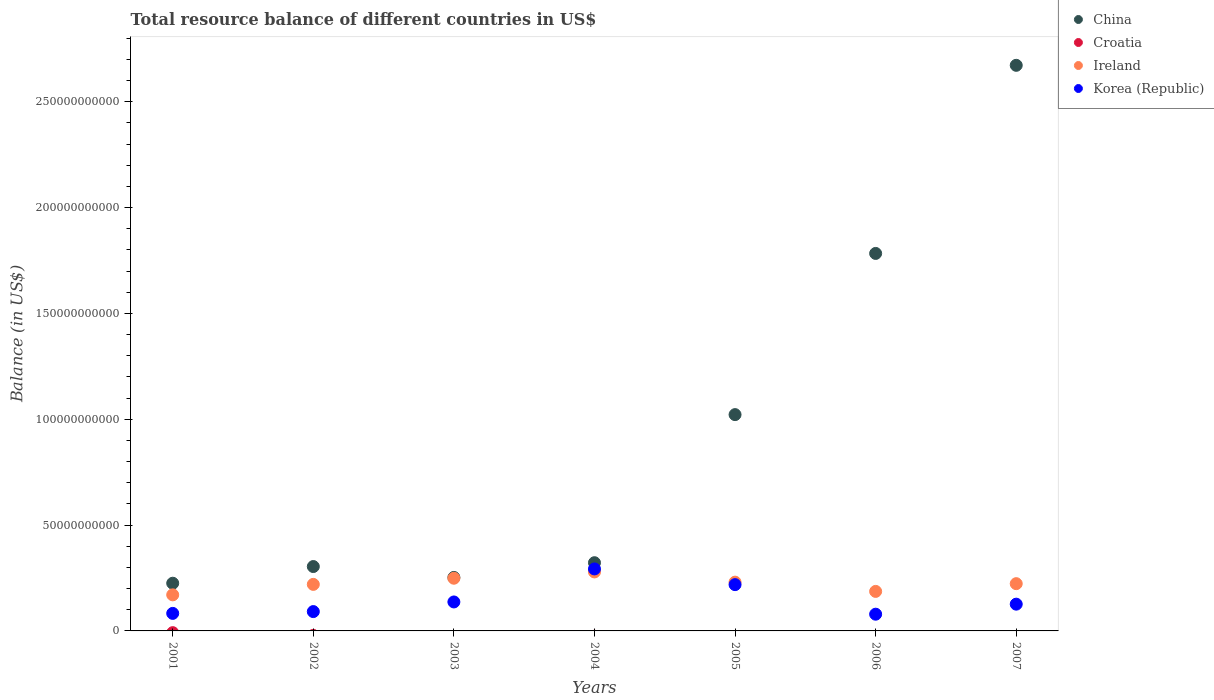Is the number of dotlines equal to the number of legend labels?
Offer a very short reply. No. What is the total resource balance in Korea (Republic) in 2006?
Offer a very short reply. 7.90e+09. Across all years, what is the maximum total resource balance in Korea (Republic)?
Offer a terse response. 2.93e+1. Across all years, what is the minimum total resource balance in Ireland?
Give a very brief answer. 1.70e+1. In which year was the total resource balance in Korea (Republic) maximum?
Provide a succinct answer. 2004. What is the total total resource balance in China in the graph?
Offer a very short reply. 6.58e+11. What is the difference between the total resource balance in Korea (Republic) in 2004 and that in 2005?
Provide a short and direct response. 7.42e+09. What is the difference between the total resource balance in Croatia in 2006 and the total resource balance in China in 2001?
Offer a very short reply. -2.25e+1. What is the average total resource balance in China per year?
Make the answer very short. 9.40e+1. In the year 2006, what is the difference between the total resource balance in China and total resource balance in Korea (Republic)?
Provide a short and direct response. 1.70e+11. What is the ratio of the total resource balance in Korea (Republic) in 2002 to that in 2003?
Make the answer very short. 0.67. Is the difference between the total resource balance in China in 2001 and 2003 greater than the difference between the total resource balance in Korea (Republic) in 2001 and 2003?
Provide a succinct answer. Yes. What is the difference between the highest and the second highest total resource balance in China?
Provide a short and direct response. 8.89e+1. What is the difference between the highest and the lowest total resource balance in China?
Give a very brief answer. 2.45e+11. Is the sum of the total resource balance in China in 2002 and 2007 greater than the maximum total resource balance in Ireland across all years?
Keep it short and to the point. Yes. Is it the case that in every year, the sum of the total resource balance in Korea (Republic) and total resource balance in Croatia  is greater than the total resource balance in Ireland?
Your answer should be very brief. No. Does the total resource balance in Croatia monotonically increase over the years?
Provide a short and direct response. No. Is the total resource balance in Korea (Republic) strictly less than the total resource balance in China over the years?
Provide a succinct answer. Yes. Does the graph contain any zero values?
Your answer should be very brief. Yes. How are the legend labels stacked?
Ensure brevity in your answer.  Vertical. What is the title of the graph?
Keep it short and to the point. Total resource balance of different countries in US$. What is the label or title of the Y-axis?
Make the answer very short. Balance (in US$). What is the Balance (in US$) of China in 2001?
Ensure brevity in your answer.  2.25e+1. What is the Balance (in US$) in Croatia in 2001?
Your answer should be very brief. 0. What is the Balance (in US$) of Ireland in 2001?
Provide a short and direct response. 1.70e+1. What is the Balance (in US$) of Korea (Republic) in 2001?
Offer a terse response. 8.28e+09. What is the Balance (in US$) in China in 2002?
Provide a succinct answer. 3.04e+1. What is the Balance (in US$) of Croatia in 2002?
Give a very brief answer. 0. What is the Balance (in US$) of Ireland in 2002?
Ensure brevity in your answer.  2.20e+1. What is the Balance (in US$) of Korea (Republic) in 2002?
Provide a short and direct response. 9.14e+09. What is the Balance (in US$) in China in 2003?
Make the answer very short. 2.53e+1. What is the Balance (in US$) in Croatia in 2003?
Keep it short and to the point. 0. What is the Balance (in US$) of Ireland in 2003?
Your answer should be very brief. 2.49e+1. What is the Balance (in US$) of Korea (Republic) in 2003?
Make the answer very short. 1.37e+1. What is the Balance (in US$) in China in 2004?
Your answer should be compact. 3.22e+1. What is the Balance (in US$) in Ireland in 2004?
Offer a terse response. 2.79e+1. What is the Balance (in US$) in Korea (Republic) in 2004?
Your answer should be very brief. 2.93e+1. What is the Balance (in US$) in China in 2005?
Your response must be concise. 1.02e+11. What is the Balance (in US$) in Ireland in 2005?
Your answer should be very brief. 2.30e+1. What is the Balance (in US$) of Korea (Republic) in 2005?
Your answer should be very brief. 2.19e+1. What is the Balance (in US$) of China in 2006?
Give a very brief answer. 1.78e+11. What is the Balance (in US$) of Ireland in 2006?
Keep it short and to the point. 1.87e+1. What is the Balance (in US$) in Korea (Republic) in 2006?
Your answer should be very brief. 7.90e+09. What is the Balance (in US$) of China in 2007?
Provide a short and direct response. 2.67e+11. What is the Balance (in US$) in Croatia in 2007?
Provide a short and direct response. 0. What is the Balance (in US$) of Ireland in 2007?
Ensure brevity in your answer.  2.23e+1. What is the Balance (in US$) of Korea (Republic) in 2007?
Your answer should be very brief. 1.26e+1. Across all years, what is the maximum Balance (in US$) in China?
Offer a terse response. 2.67e+11. Across all years, what is the maximum Balance (in US$) in Ireland?
Offer a terse response. 2.79e+1. Across all years, what is the maximum Balance (in US$) in Korea (Republic)?
Keep it short and to the point. 2.93e+1. Across all years, what is the minimum Balance (in US$) in China?
Provide a short and direct response. 2.25e+1. Across all years, what is the minimum Balance (in US$) in Ireland?
Keep it short and to the point. 1.70e+1. Across all years, what is the minimum Balance (in US$) in Korea (Republic)?
Give a very brief answer. 7.90e+09. What is the total Balance (in US$) in China in the graph?
Provide a short and direct response. 6.58e+11. What is the total Balance (in US$) of Croatia in the graph?
Make the answer very short. 0. What is the total Balance (in US$) of Ireland in the graph?
Offer a terse response. 1.56e+11. What is the total Balance (in US$) of Korea (Republic) in the graph?
Offer a terse response. 1.03e+11. What is the difference between the Balance (in US$) in China in 2001 and that in 2002?
Make the answer very short. -7.88e+09. What is the difference between the Balance (in US$) of Ireland in 2001 and that in 2002?
Ensure brevity in your answer.  -4.94e+09. What is the difference between the Balance (in US$) in Korea (Republic) in 2001 and that in 2002?
Your answer should be very brief. -8.53e+08. What is the difference between the Balance (in US$) in China in 2001 and that in 2003?
Offer a very short reply. -2.74e+09. What is the difference between the Balance (in US$) of Ireland in 2001 and that in 2003?
Provide a succinct answer. -7.84e+09. What is the difference between the Balance (in US$) of Korea (Republic) in 2001 and that in 2003?
Keep it short and to the point. -5.40e+09. What is the difference between the Balance (in US$) of China in 2001 and that in 2004?
Provide a succinct answer. -9.69e+09. What is the difference between the Balance (in US$) of Ireland in 2001 and that in 2004?
Offer a very short reply. -1.08e+1. What is the difference between the Balance (in US$) in Korea (Republic) in 2001 and that in 2004?
Your answer should be very brief. -2.10e+1. What is the difference between the Balance (in US$) of China in 2001 and that in 2005?
Your response must be concise. -7.97e+1. What is the difference between the Balance (in US$) in Ireland in 2001 and that in 2005?
Provide a succinct answer. -6.00e+09. What is the difference between the Balance (in US$) of Korea (Republic) in 2001 and that in 2005?
Ensure brevity in your answer.  -1.36e+1. What is the difference between the Balance (in US$) of China in 2001 and that in 2006?
Offer a terse response. -1.56e+11. What is the difference between the Balance (in US$) of Ireland in 2001 and that in 2006?
Ensure brevity in your answer.  -1.62e+09. What is the difference between the Balance (in US$) in Korea (Republic) in 2001 and that in 2006?
Keep it short and to the point. 3.79e+08. What is the difference between the Balance (in US$) in China in 2001 and that in 2007?
Your answer should be compact. -2.45e+11. What is the difference between the Balance (in US$) of Ireland in 2001 and that in 2007?
Make the answer very short. -5.28e+09. What is the difference between the Balance (in US$) of Korea (Republic) in 2001 and that in 2007?
Your answer should be compact. -4.36e+09. What is the difference between the Balance (in US$) in China in 2002 and that in 2003?
Make the answer very short. 5.14e+09. What is the difference between the Balance (in US$) in Ireland in 2002 and that in 2003?
Provide a short and direct response. -2.91e+09. What is the difference between the Balance (in US$) in Korea (Republic) in 2002 and that in 2003?
Give a very brief answer. -4.55e+09. What is the difference between the Balance (in US$) of China in 2002 and that in 2004?
Provide a succinct answer. -1.81e+09. What is the difference between the Balance (in US$) of Ireland in 2002 and that in 2004?
Provide a short and direct response. -5.88e+09. What is the difference between the Balance (in US$) in Korea (Republic) in 2002 and that in 2004?
Provide a succinct answer. -2.02e+1. What is the difference between the Balance (in US$) in China in 2002 and that in 2005?
Provide a succinct answer. -7.18e+1. What is the difference between the Balance (in US$) in Ireland in 2002 and that in 2005?
Offer a terse response. -1.06e+09. What is the difference between the Balance (in US$) of Korea (Republic) in 2002 and that in 2005?
Provide a succinct answer. -1.27e+1. What is the difference between the Balance (in US$) in China in 2002 and that in 2006?
Offer a very short reply. -1.48e+11. What is the difference between the Balance (in US$) in Ireland in 2002 and that in 2006?
Your answer should be very brief. 3.31e+09. What is the difference between the Balance (in US$) in Korea (Republic) in 2002 and that in 2006?
Give a very brief answer. 1.23e+09. What is the difference between the Balance (in US$) of China in 2002 and that in 2007?
Provide a short and direct response. -2.37e+11. What is the difference between the Balance (in US$) of Ireland in 2002 and that in 2007?
Make the answer very short. -3.39e+08. What is the difference between the Balance (in US$) of Korea (Republic) in 2002 and that in 2007?
Keep it short and to the point. -3.51e+09. What is the difference between the Balance (in US$) of China in 2003 and that in 2004?
Your answer should be compact. -6.95e+09. What is the difference between the Balance (in US$) of Ireland in 2003 and that in 2004?
Provide a short and direct response. -2.98e+09. What is the difference between the Balance (in US$) in Korea (Republic) in 2003 and that in 2004?
Provide a succinct answer. -1.56e+1. What is the difference between the Balance (in US$) in China in 2003 and that in 2005?
Your response must be concise. -7.69e+1. What is the difference between the Balance (in US$) in Ireland in 2003 and that in 2005?
Give a very brief answer. 1.85e+09. What is the difference between the Balance (in US$) in Korea (Republic) in 2003 and that in 2005?
Offer a terse response. -8.18e+09. What is the difference between the Balance (in US$) in China in 2003 and that in 2006?
Make the answer very short. -1.53e+11. What is the difference between the Balance (in US$) in Ireland in 2003 and that in 2006?
Provide a succinct answer. 6.22e+09. What is the difference between the Balance (in US$) of Korea (Republic) in 2003 and that in 2006?
Offer a terse response. 5.78e+09. What is the difference between the Balance (in US$) of China in 2003 and that in 2007?
Keep it short and to the point. -2.42e+11. What is the difference between the Balance (in US$) in Ireland in 2003 and that in 2007?
Offer a very short reply. 2.57e+09. What is the difference between the Balance (in US$) in Korea (Republic) in 2003 and that in 2007?
Offer a terse response. 1.04e+09. What is the difference between the Balance (in US$) in China in 2004 and that in 2005?
Provide a short and direct response. -7.00e+1. What is the difference between the Balance (in US$) of Ireland in 2004 and that in 2005?
Make the answer very short. 4.83e+09. What is the difference between the Balance (in US$) of Korea (Republic) in 2004 and that in 2005?
Keep it short and to the point. 7.42e+09. What is the difference between the Balance (in US$) in China in 2004 and that in 2006?
Give a very brief answer. -1.46e+11. What is the difference between the Balance (in US$) in Ireland in 2004 and that in 2006?
Ensure brevity in your answer.  9.20e+09. What is the difference between the Balance (in US$) of Korea (Republic) in 2004 and that in 2006?
Give a very brief answer. 2.14e+1. What is the difference between the Balance (in US$) in China in 2004 and that in 2007?
Your answer should be very brief. -2.35e+11. What is the difference between the Balance (in US$) in Ireland in 2004 and that in 2007?
Keep it short and to the point. 5.55e+09. What is the difference between the Balance (in US$) in Korea (Republic) in 2004 and that in 2007?
Provide a succinct answer. 1.66e+1. What is the difference between the Balance (in US$) in China in 2005 and that in 2006?
Your answer should be very brief. -7.62e+1. What is the difference between the Balance (in US$) of Ireland in 2005 and that in 2006?
Offer a terse response. 4.37e+09. What is the difference between the Balance (in US$) in Korea (Republic) in 2005 and that in 2006?
Your answer should be very brief. 1.40e+1. What is the difference between the Balance (in US$) in China in 2005 and that in 2007?
Keep it short and to the point. -1.65e+11. What is the difference between the Balance (in US$) of Ireland in 2005 and that in 2007?
Your answer should be compact. 7.20e+08. What is the difference between the Balance (in US$) in Korea (Republic) in 2005 and that in 2007?
Your answer should be compact. 9.22e+09. What is the difference between the Balance (in US$) of China in 2006 and that in 2007?
Offer a terse response. -8.89e+1. What is the difference between the Balance (in US$) in Ireland in 2006 and that in 2007?
Make the answer very short. -3.65e+09. What is the difference between the Balance (in US$) in Korea (Republic) in 2006 and that in 2007?
Your answer should be very brief. -4.74e+09. What is the difference between the Balance (in US$) in China in 2001 and the Balance (in US$) in Ireland in 2002?
Make the answer very short. 5.48e+08. What is the difference between the Balance (in US$) of China in 2001 and the Balance (in US$) of Korea (Republic) in 2002?
Your answer should be compact. 1.34e+1. What is the difference between the Balance (in US$) of Ireland in 2001 and the Balance (in US$) of Korea (Republic) in 2002?
Provide a short and direct response. 7.91e+09. What is the difference between the Balance (in US$) in China in 2001 and the Balance (in US$) in Ireland in 2003?
Your response must be concise. -2.36e+09. What is the difference between the Balance (in US$) of China in 2001 and the Balance (in US$) of Korea (Republic) in 2003?
Provide a succinct answer. 8.85e+09. What is the difference between the Balance (in US$) in Ireland in 2001 and the Balance (in US$) in Korea (Republic) in 2003?
Ensure brevity in your answer.  3.36e+09. What is the difference between the Balance (in US$) in China in 2001 and the Balance (in US$) in Ireland in 2004?
Make the answer very short. -5.34e+09. What is the difference between the Balance (in US$) of China in 2001 and the Balance (in US$) of Korea (Republic) in 2004?
Provide a short and direct response. -6.75e+09. What is the difference between the Balance (in US$) of Ireland in 2001 and the Balance (in US$) of Korea (Republic) in 2004?
Provide a short and direct response. -1.22e+1. What is the difference between the Balance (in US$) in China in 2001 and the Balance (in US$) in Ireland in 2005?
Offer a terse response. -5.11e+08. What is the difference between the Balance (in US$) of China in 2001 and the Balance (in US$) of Korea (Republic) in 2005?
Your response must be concise. 6.65e+08. What is the difference between the Balance (in US$) in Ireland in 2001 and the Balance (in US$) in Korea (Republic) in 2005?
Keep it short and to the point. -4.82e+09. What is the difference between the Balance (in US$) in China in 2001 and the Balance (in US$) in Ireland in 2006?
Your answer should be compact. 3.86e+09. What is the difference between the Balance (in US$) in China in 2001 and the Balance (in US$) in Korea (Republic) in 2006?
Your answer should be very brief. 1.46e+1. What is the difference between the Balance (in US$) of Ireland in 2001 and the Balance (in US$) of Korea (Republic) in 2006?
Provide a succinct answer. 9.14e+09. What is the difference between the Balance (in US$) in China in 2001 and the Balance (in US$) in Ireland in 2007?
Offer a very short reply. 2.09e+08. What is the difference between the Balance (in US$) in China in 2001 and the Balance (in US$) in Korea (Republic) in 2007?
Your answer should be very brief. 9.89e+09. What is the difference between the Balance (in US$) in Ireland in 2001 and the Balance (in US$) in Korea (Republic) in 2007?
Your answer should be compact. 4.40e+09. What is the difference between the Balance (in US$) of China in 2002 and the Balance (in US$) of Ireland in 2003?
Give a very brief answer. 5.52e+09. What is the difference between the Balance (in US$) of China in 2002 and the Balance (in US$) of Korea (Republic) in 2003?
Make the answer very short. 1.67e+1. What is the difference between the Balance (in US$) in Ireland in 2002 and the Balance (in US$) in Korea (Republic) in 2003?
Make the answer very short. 8.30e+09. What is the difference between the Balance (in US$) of China in 2002 and the Balance (in US$) of Ireland in 2004?
Give a very brief answer. 2.55e+09. What is the difference between the Balance (in US$) of China in 2002 and the Balance (in US$) of Korea (Republic) in 2004?
Make the answer very short. 1.13e+09. What is the difference between the Balance (in US$) in Ireland in 2002 and the Balance (in US$) in Korea (Republic) in 2004?
Offer a terse response. -7.30e+09. What is the difference between the Balance (in US$) of China in 2002 and the Balance (in US$) of Ireland in 2005?
Your answer should be compact. 7.37e+09. What is the difference between the Balance (in US$) in China in 2002 and the Balance (in US$) in Korea (Republic) in 2005?
Your response must be concise. 8.55e+09. What is the difference between the Balance (in US$) of Ireland in 2002 and the Balance (in US$) of Korea (Republic) in 2005?
Your answer should be very brief. 1.17e+08. What is the difference between the Balance (in US$) in China in 2002 and the Balance (in US$) in Ireland in 2006?
Give a very brief answer. 1.17e+1. What is the difference between the Balance (in US$) in China in 2002 and the Balance (in US$) in Korea (Republic) in 2006?
Ensure brevity in your answer.  2.25e+1. What is the difference between the Balance (in US$) in Ireland in 2002 and the Balance (in US$) in Korea (Republic) in 2006?
Offer a very short reply. 1.41e+1. What is the difference between the Balance (in US$) in China in 2002 and the Balance (in US$) in Ireland in 2007?
Ensure brevity in your answer.  8.09e+09. What is the difference between the Balance (in US$) of China in 2002 and the Balance (in US$) of Korea (Republic) in 2007?
Provide a short and direct response. 1.78e+1. What is the difference between the Balance (in US$) of Ireland in 2002 and the Balance (in US$) of Korea (Republic) in 2007?
Your response must be concise. 9.34e+09. What is the difference between the Balance (in US$) of China in 2003 and the Balance (in US$) of Ireland in 2004?
Provide a short and direct response. -2.59e+09. What is the difference between the Balance (in US$) in China in 2003 and the Balance (in US$) in Korea (Republic) in 2004?
Offer a very short reply. -4.01e+09. What is the difference between the Balance (in US$) in Ireland in 2003 and the Balance (in US$) in Korea (Republic) in 2004?
Make the answer very short. -4.39e+09. What is the difference between the Balance (in US$) of China in 2003 and the Balance (in US$) of Ireland in 2005?
Your response must be concise. 2.23e+09. What is the difference between the Balance (in US$) in China in 2003 and the Balance (in US$) in Korea (Republic) in 2005?
Keep it short and to the point. 3.41e+09. What is the difference between the Balance (in US$) in Ireland in 2003 and the Balance (in US$) in Korea (Republic) in 2005?
Your answer should be compact. 3.02e+09. What is the difference between the Balance (in US$) of China in 2003 and the Balance (in US$) of Ireland in 2006?
Offer a terse response. 6.61e+09. What is the difference between the Balance (in US$) of China in 2003 and the Balance (in US$) of Korea (Republic) in 2006?
Provide a short and direct response. 1.74e+1. What is the difference between the Balance (in US$) of Ireland in 2003 and the Balance (in US$) of Korea (Republic) in 2006?
Your answer should be very brief. 1.70e+1. What is the difference between the Balance (in US$) in China in 2003 and the Balance (in US$) in Ireland in 2007?
Your response must be concise. 2.95e+09. What is the difference between the Balance (in US$) in China in 2003 and the Balance (in US$) in Korea (Republic) in 2007?
Ensure brevity in your answer.  1.26e+1. What is the difference between the Balance (in US$) of Ireland in 2003 and the Balance (in US$) of Korea (Republic) in 2007?
Offer a terse response. 1.22e+1. What is the difference between the Balance (in US$) of China in 2004 and the Balance (in US$) of Ireland in 2005?
Give a very brief answer. 9.18e+09. What is the difference between the Balance (in US$) in China in 2004 and the Balance (in US$) in Korea (Republic) in 2005?
Keep it short and to the point. 1.04e+1. What is the difference between the Balance (in US$) in Ireland in 2004 and the Balance (in US$) in Korea (Republic) in 2005?
Your response must be concise. 6.00e+09. What is the difference between the Balance (in US$) of China in 2004 and the Balance (in US$) of Ireland in 2006?
Your response must be concise. 1.36e+1. What is the difference between the Balance (in US$) of China in 2004 and the Balance (in US$) of Korea (Republic) in 2006?
Offer a very short reply. 2.43e+1. What is the difference between the Balance (in US$) in Ireland in 2004 and the Balance (in US$) in Korea (Republic) in 2006?
Provide a short and direct response. 2.00e+1. What is the difference between the Balance (in US$) of China in 2004 and the Balance (in US$) of Ireland in 2007?
Keep it short and to the point. 9.90e+09. What is the difference between the Balance (in US$) in China in 2004 and the Balance (in US$) in Korea (Republic) in 2007?
Give a very brief answer. 1.96e+1. What is the difference between the Balance (in US$) in Ireland in 2004 and the Balance (in US$) in Korea (Republic) in 2007?
Offer a very short reply. 1.52e+1. What is the difference between the Balance (in US$) in China in 2005 and the Balance (in US$) in Ireland in 2006?
Provide a succinct answer. 8.35e+1. What is the difference between the Balance (in US$) in China in 2005 and the Balance (in US$) in Korea (Republic) in 2006?
Your answer should be compact. 9.43e+1. What is the difference between the Balance (in US$) in Ireland in 2005 and the Balance (in US$) in Korea (Republic) in 2006?
Your answer should be compact. 1.51e+1. What is the difference between the Balance (in US$) of China in 2005 and the Balance (in US$) of Ireland in 2007?
Your response must be concise. 7.99e+1. What is the difference between the Balance (in US$) in China in 2005 and the Balance (in US$) in Korea (Republic) in 2007?
Provide a succinct answer. 8.96e+1. What is the difference between the Balance (in US$) of Ireland in 2005 and the Balance (in US$) of Korea (Republic) in 2007?
Keep it short and to the point. 1.04e+1. What is the difference between the Balance (in US$) in China in 2006 and the Balance (in US$) in Ireland in 2007?
Provide a succinct answer. 1.56e+11. What is the difference between the Balance (in US$) of China in 2006 and the Balance (in US$) of Korea (Republic) in 2007?
Make the answer very short. 1.66e+11. What is the difference between the Balance (in US$) of Ireland in 2006 and the Balance (in US$) of Korea (Republic) in 2007?
Ensure brevity in your answer.  6.03e+09. What is the average Balance (in US$) in China per year?
Your answer should be compact. 9.40e+1. What is the average Balance (in US$) of Ireland per year?
Provide a succinct answer. 2.23e+1. What is the average Balance (in US$) in Korea (Republic) per year?
Make the answer very short. 1.47e+1. In the year 2001, what is the difference between the Balance (in US$) of China and Balance (in US$) of Ireland?
Provide a short and direct response. 5.49e+09. In the year 2001, what is the difference between the Balance (in US$) of China and Balance (in US$) of Korea (Republic)?
Keep it short and to the point. 1.43e+1. In the year 2001, what is the difference between the Balance (in US$) in Ireland and Balance (in US$) in Korea (Republic)?
Offer a very short reply. 8.77e+09. In the year 2002, what is the difference between the Balance (in US$) of China and Balance (in US$) of Ireland?
Give a very brief answer. 8.43e+09. In the year 2002, what is the difference between the Balance (in US$) of China and Balance (in US$) of Korea (Republic)?
Provide a succinct answer. 2.13e+1. In the year 2002, what is the difference between the Balance (in US$) of Ireland and Balance (in US$) of Korea (Republic)?
Make the answer very short. 1.29e+1. In the year 2003, what is the difference between the Balance (in US$) of China and Balance (in US$) of Ireland?
Your answer should be very brief. 3.86e+08. In the year 2003, what is the difference between the Balance (in US$) of China and Balance (in US$) of Korea (Republic)?
Ensure brevity in your answer.  1.16e+1. In the year 2003, what is the difference between the Balance (in US$) of Ireland and Balance (in US$) of Korea (Republic)?
Provide a short and direct response. 1.12e+1. In the year 2004, what is the difference between the Balance (in US$) in China and Balance (in US$) in Ireland?
Your response must be concise. 4.36e+09. In the year 2004, what is the difference between the Balance (in US$) in China and Balance (in US$) in Korea (Republic)?
Keep it short and to the point. 2.94e+09. In the year 2004, what is the difference between the Balance (in US$) of Ireland and Balance (in US$) of Korea (Republic)?
Give a very brief answer. -1.42e+09. In the year 2005, what is the difference between the Balance (in US$) of China and Balance (in US$) of Ireland?
Keep it short and to the point. 7.92e+1. In the year 2005, what is the difference between the Balance (in US$) of China and Balance (in US$) of Korea (Republic)?
Your answer should be very brief. 8.03e+1. In the year 2005, what is the difference between the Balance (in US$) in Ireland and Balance (in US$) in Korea (Republic)?
Ensure brevity in your answer.  1.18e+09. In the year 2006, what is the difference between the Balance (in US$) in China and Balance (in US$) in Ireland?
Offer a very short reply. 1.60e+11. In the year 2006, what is the difference between the Balance (in US$) of China and Balance (in US$) of Korea (Republic)?
Your answer should be very brief. 1.70e+11. In the year 2006, what is the difference between the Balance (in US$) in Ireland and Balance (in US$) in Korea (Republic)?
Keep it short and to the point. 1.08e+1. In the year 2007, what is the difference between the Balance (in US$) of China and Balance (in US$) of Ireland?
Offer a very short reply. 2.45e+11. In the year 2007, what is the difference between the Balance (in US$) of China and Balance (in US$) of Korea (Republic)?
Offer a very short reply. 2.55e+11. In the year 2007, what is the difference between the Balance (in US$) of Ireland and Balance (in US$) of Korea (Republic)?
Ensure brevity in your answer.  9.68e+09. What is the ratio of the Balance (in US$) of China in 2001 to that in 2002?
Offer a terse response. 0.74. What is the ratio of the Balance (in US$) of Ireland in 2001 to that in 2002?
Make the answer very short. 0.78. What is the ratio of the Balance (in US$) of Korea (Republic) in 2001 to that in 2002?
Your response must be concise. 0.91. What is the ratio of the Balance (in US$) in China in 2001 to that in 2003?
Your answer should be very brief. 0.89. What is the ratio of the Balance (in US$) of Ireland in 2001 to that in 2003?
Keep it short and to the point. 0.68. What is the ratio of the Balance (in US$) in Korea (Republic) in 2001 to that in 2003?
Provide a short and direct response. 0.61. What is the ratio of the Balance (in US$) in China in 2001 to that in 2004?
Provide a short and direct response. 0.7. What is the ratio of the Balance (in US$) in Ireland in 2001 to that in 2004?
Your answer should be very brief. 0.61. What is the ratio of the Balance (in US$) in Korea (Republic) in 2001 to that in 2004?
Keep it short and to the point. 0.28. What is the ratio of the Balance (in US$) in China in 2001 to that in 2005?
Provide a short and direct response. 0.22. What is the ratio of the Balance (in US$) in Ireland in 2001 to that in 2005?
Ensure brevity in your answer.  0.74. What is the ratio of the Balance (in US$) in Korea (Republic) in 2001 to that in 2005?
Your answer should be compact. 0.38. What is the ratio of the Balance (in US$) of China in 2001 to that in 2006?
Provide a succinct answer. 0.13. What is the ratio of the Balance (in US$) of Korea (Republic) in 2001 to that in 2006?
Make the answer very short. 1.05. What is the ratio of the Balance (in US$) in China in 2001 to that in 2007?
Provide a short and direct response. 0.08. What is the ratio of the Balance (in US$) of Ireland in 2001 to that in 2007?
Provide a succinct answer. 0.76. What is the ratio of the Balance (in US$) of Korea (Republic) in 2001 to that in 2007?
Give a very brief answer. 0.66. What is the ratio of the Balance (in US$) in China in 2002 to that in 2003?
Make the answer very short. 1.2. What is the ratio of the Balance (in US$) in Ireland in 2002 to that in 2003?
Offer a very short reply. 0.88. What is the ratio of the Balance (in US$) in Korea (Republic) in 2002 to that in 2003?
Your response must be concise. 0.67. What is the ratio of the Balance (in US$) of China in 2002 to that in 2004?
Offer a terse response. 0.94. What is the ratio of the Balance (in US$) in Ireland in 2002 to that in 2004?
Your answer should be compact. 0.79. What is the ratio of the Balance (in US$) of Korea (Republic) in 2002 to that in 2004?
Provide a short and direct response. 0.31. What is the ratio of the Balance (in US$) in China in 2002 to that in 2005?
Offer a terse response. 0.3. What is the ratio of the Balance (in US$) in Ireland in 2002 to that in 2005?
Keep it short and to the point. 0.95. What is the ratio of the Balance (in US$) of Korea (Republic) in 2002 to that in 2005?
Your response must be concise. 0.42. What is the ratio of the Balance (in US$) in China in 2002 to that in 2006?
Make the answer very short. 0.17. What is the ratio of the Balance (in US$) of Ireland in 2002 to that in 2006?
Provide a short and direct response. 1.18. What is the ratio of the Balance (in US$) of Korea (Republic) in 2002 to that in 2006?
Offer a terse response. 1.16. What is the ratio of the Balance (in US$) in China in 2002 to that in 2007?
Your response must be concise. 0.11. What is the ratio of the Balance (in US$) in Ireland in 2002 to that in 2007?
Keep it short and to the point. 0.98. What is the ratio of the Balance (in US$) of Korea (Republic) in 2002 to that in 2007?
Your response must be concise. 0.72. What is the ratio of the Balance (in US$) of China in 2003 to that in 2004?
Ensure brevity in your answer.  0.78. What is the ratio of the Balance (in US$) in Ireland in 2003 to that in 2004?
Offer a very short reply. 0.89. What is the ratio of the Balance (in US$) of Korea (Republic) in 2003 to that in 2004?
Offer a very short reply. 0.47. What is the ratio of the Balance (in US$) of China in 2003 to that in 2005?
Provide a succinct answer. 0.25. What is the ratio of the Balance (in US$) in Ireland in 2003 to that in 2005?
Provide a short and direct response. 1.08. What is the ratio of the Balance (in US$) of Korea (Republic) in 2003 to that in 2005?
Make the answer very short. 0.63. What is the ratio of the Balance (in US$) of China in 2003 to that in 2006?
Make the answer very short. 0.14. What is the ratio of the Balance (in US$) in Ireland in 2003 to that in 2006?
Your answer should be compact. 1.33. What is the ratio of the Balance (in US$) in Korea (Republic) in 2003 to that in 2006?
Ensure brevity in your answer.  1.73. What is the ratio of the Balance (in US$) in China in 2003 to that in 2007?
Ensure brevity in your answer.  0.09. What is the ratio of the Balance (in US$) in Ireland in 2003 to that in 2007?
Offer a terse response. 1.11. What is the ratio of the Balance (in US$) of Korea (Republic) in 2003 to that in 2007?
Ensure brevity in your answer.  1.08. What is the ratio of the Balance (in US$) of China in 2004 to that in 2005?
Your answer should be very brief. 0.32. What is the ratio of the Balance (in US$) in Ireland in 2004 to that in 2005?
Keep it short and to the point. 1.21. What is the ratio of the Balance (in US$) of Korea (Republic) in 2004 to that in 2005?
Provide a succinct answer. 1.34. What is the ratio of the Balance (in US$) in China in 2004 to that in 2006?
Provide a short and direct response. 0.18. What is the ratio of the Balance (in US$) of Ireland in 2004 to that in 2006?
Your answer should be very brief. 1.49. What is the ratio of the Balance (in US$) of Korea (Republic) in 2004 to that in 2006?
Your response must be concise. 3.71. What is the ratio of the Balance (in US$) of China in 2004 to that in 2007?
Provide a succinct answer. 0.12. What is the ratio of the Balance (in US$) in Ireland in 2004 to that in 2007?
Your answer should be very brief. 1.25. What is the ratio of the Balance (in US$) in Korea (Republic) in 2004 to that in 2007?
Ensure brevity in your answer.  2.32. What is the ratio of the Balance (in US$) in China in 2005 to that in 2006?
Ensure brevity in your answer.  0.57. What is the ratio of the Balance (in US$) in Ireland in 2005 to that in 2006?
Provide a short and direct response. 1.23. What is the ratio of the Balance (in US$) in Korea (Republic) in 2005 to that in 2006?
Offer a terse response. 2.77. What is the ratio of the Balance (in US$) in China in 2005 to that in 2007?
Provide a succinct answer. 0.38. What is the ratio of the Balance (in US$) of Ireland in 2005 to that in 2007?
Provide a short and direct response. 1.03. What is the ratio of the Balance (in US$) of Korea (Republic) in 2005 to that in 2007?
Make the answer very short. 1.73. What is the ratio of the Balance (in US$) of China in 2006 to that in 2007?
Keep it short and to the point. 0.67. What is the ratio of the Balance (in US$) of Ireland in 2006 to that in 2007?
Provide a succinct answer. 0.84. What is the ratio of the Balance (in US$) of Korea (Republic) in 2006 to that in 2007?
Offer a terse response. 0.63. What is the difference between the highest and the second highest Balance (in US$) of China?
Keep it short and to the point. 8.89e+1. What is the difference between the highest and the second highest Balance (in US$) in Ireland?
Keep it short and to the point. 2.98e+09. What is the difference between the highest and the second highest Balance (in US$) in Korea (Republic)?
Offer a terse response. 7.42e+09. What is the difference between the highest and the lowest Balance (in US$) of China?
Provide a succinct answer. 2.45e+11. What is the difference between the highest and the lowest Balance (in US$) of Ireland?
Provide a short and direct response. 1.08e+1. What is the difference between the highest and the lowest Balance (in US$) in Korea (Republic)?
Your answer should be compact. 2.14e+1. 